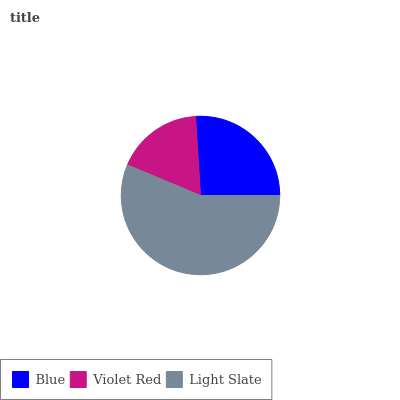Is Violet Red the minimum?
Answer yes or no. Yes. Is Light Slate the maximum?
Answer yes or no. Yes. Is Light Slate the minimum?
Answer yes or no. No. Is Violet Red the maximum?
Answer yes or no. No. Is Light Slate greater than Violet Red?
Answer yes or no. Yes. Is Violet Red less than Light Slate?
Answer yes or no. Yes. Is Violet Red greater than Light Slate?
Answer yes or no. No. Is Light Slate less than Violet Red?
Answer yes or no. No. Is Blue the high median?
Answer yes or no. Yes. Is Blue the low median?
Answer yes or no. Yes. Is Violet Red the high median?
Answer yes or no. No. Is Light Slate the low median?
Answer yes or no. No. 